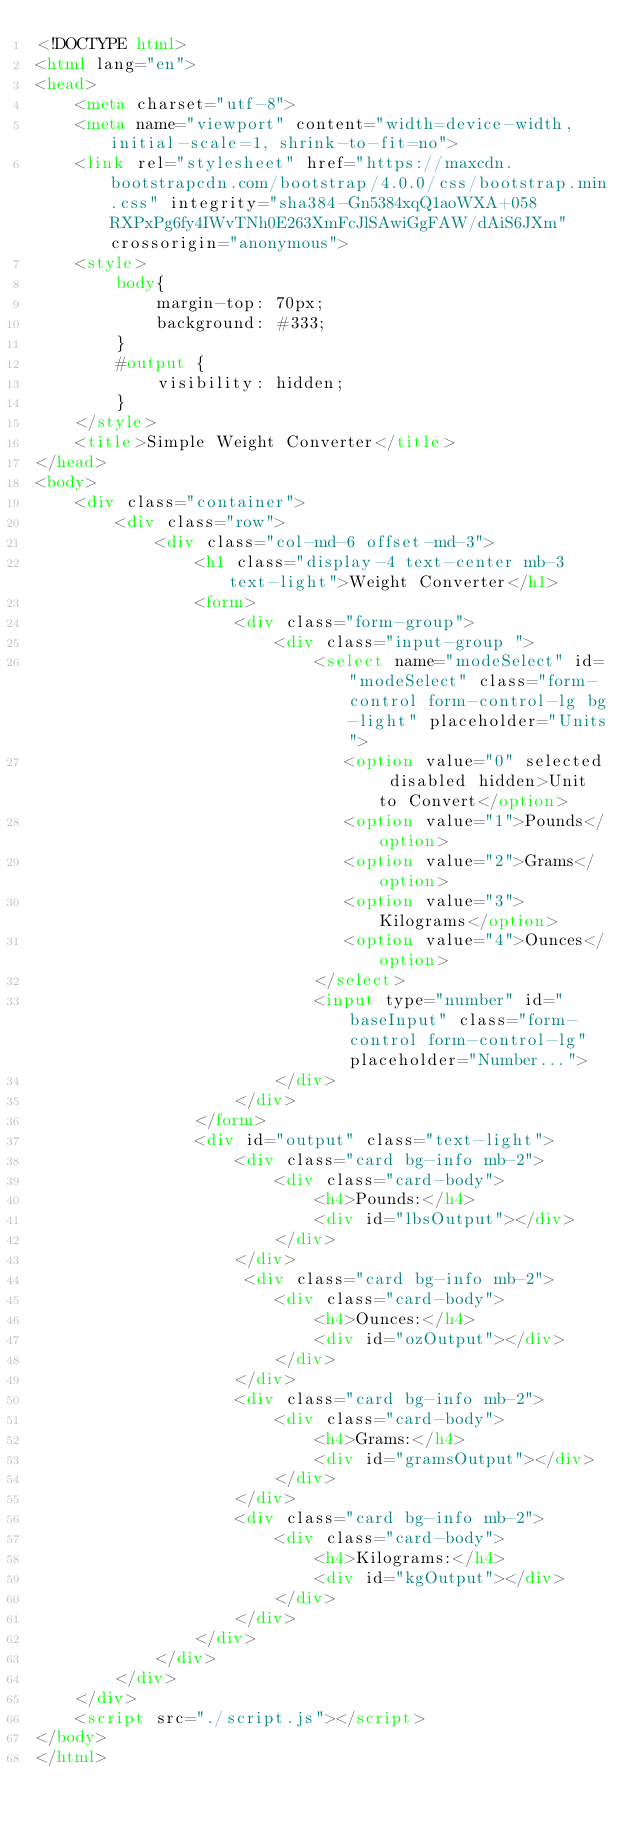Convert code to text. <code><loc_0><loc_0><loc_500><loc_500><_HTML_><!DOCTYPE html>
<html lang="en">
<head>
    <meta charset="utf-8">
    <meta name="viewport" content="width=device-width, initial-scale=1, shrink-to-fit=no">
    <link rel="stylesheet" href="https://maxcdn.bootstrapcdn.com/bootstrap/4.0.0/css/bootstrap.min.css" integrity="sha384-Gn5384xqQ1aoWXA+058RXPxPg6fy4IWvTNh0E263XmFcJlSAwiGgFAW/dAiS6JXm" crossorigin="anonymous">
    <style>
        body{
            margin-top: 70px;
            background: #333;
        }
        #output {
            visibility: hidden;
        }
    </style>
    <title>Simple Weight Converter</title>
</head>
<body>
    <div class="container">
        <div class="row">
            <div class="col-md-6 offset-md-3">
                <h1 class="display-4 text-center mb-3 text-light">Weight Converter</h1>
                <form>
                    <div class="form-group">
                        <div class="input-group ">
                            <select name="modeSelect" id="modeSelect" class="form-control form-control-lg bg-light" placeholder="Units">
                               <option value="0" selected disabled hidden>Unit to Convert</option>
                               <option value="1">Pounds</option>
                               <option value="2">Grams</option>
                               <option value="3">Kilograms</option>
                               <option value="4">Ounces</option>
                            </select>
                            <input type="number" id="baseInput" class="form-control form-control-lg" placeholder="Number...">
                        </div>
                    </div>
                </form>
                <div id="output" class="text-light">
                    <div class="card bg-info mb-2">
                        <div class="card-body">
                            <h4>Pounds:</h4>
                            <div id="lbsOutput"></div>
                        </div>
                    </div>
                     <div class="card bg-info mb-2">
                        <div class="card-body">
                            <h4>Ounces:</h4>
                            <div id="ozOutput"></div>
                        </div>
                    </div>
                    <div class="card bg-info mb-2">
                        <div class="card-body">
                            <h4>Grams:</h4>
                            <div id="gramsOutput"></div>
                        </div>
                    </div>
                    <div class="card bg-info mb-2">
                        <div class="card-body">
                            <h4>Kilograms:</h4>
                            <div id="kgOutput"></div>
                        </div>
                    </div>
                </div>
            </div>
        </div>
    </div>
    <script src="./script.js"></script>
</body>
</html>
 </code> 